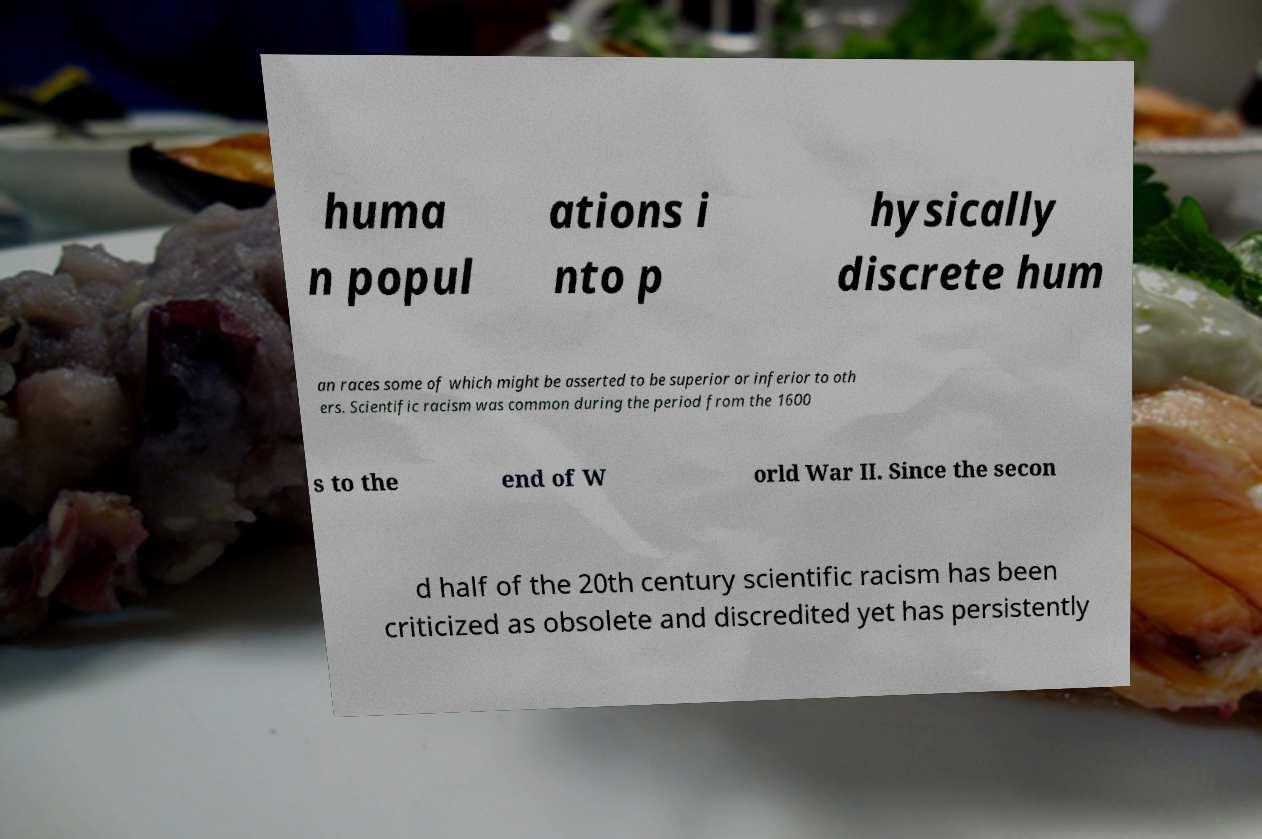Can you accurately transcribe the text from the provided image for me? huma n popul ations i nto p hysically discrete hum an races some of which might be asserted to be superior or inferior to oth ers. Scientific racism was common during the period from the 1600 s to the end of W orld War II. Since the secon d half of the 20th century scientific racism has been criticized as obsolete and discredited yet has persistently 